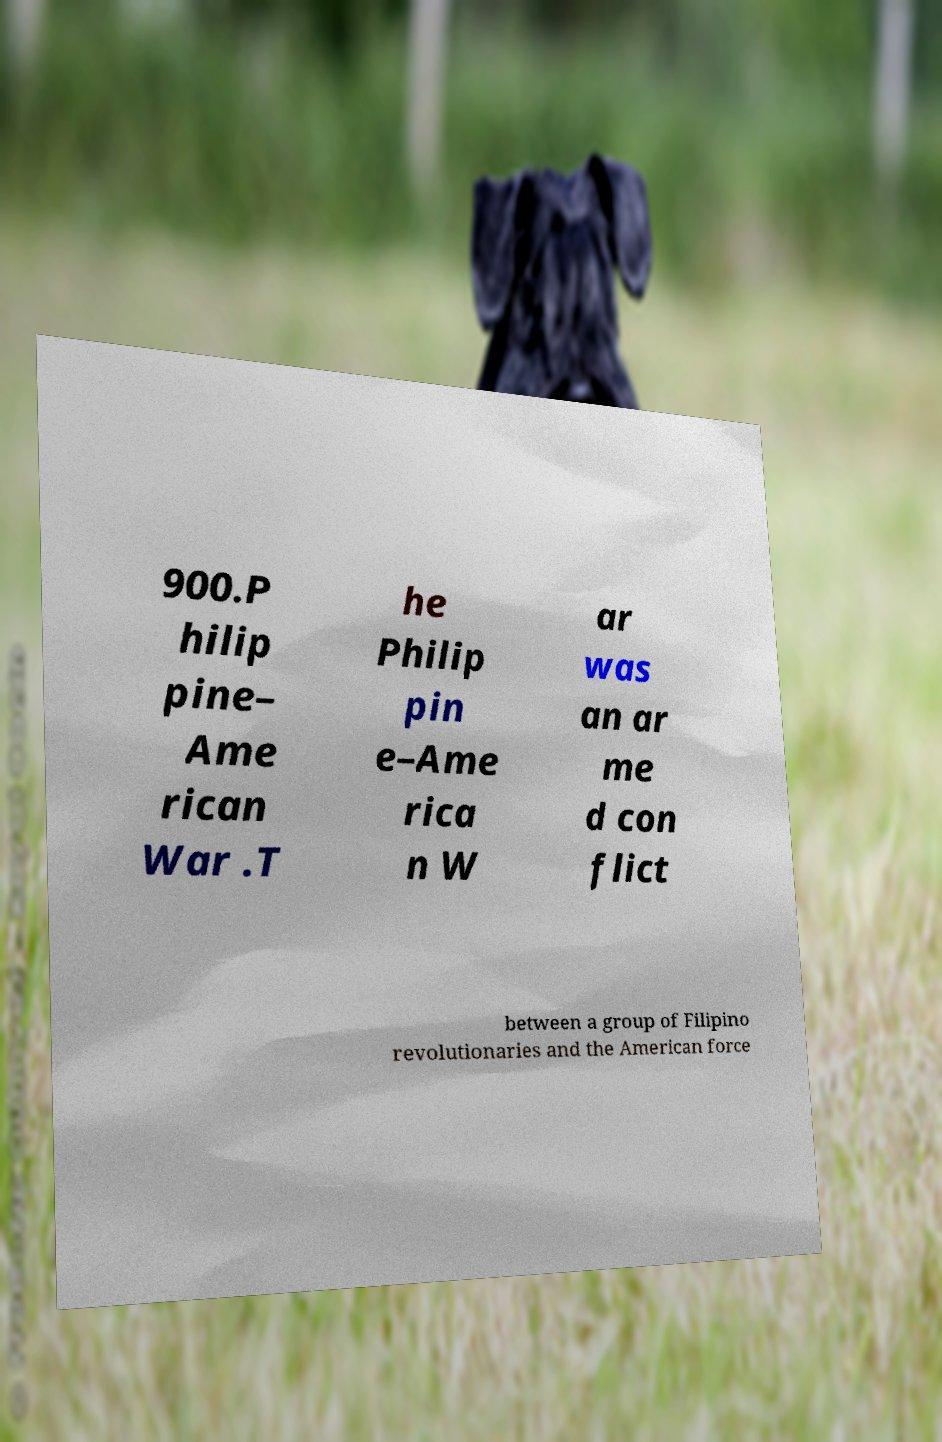Could you extract and type out the text from this image? 900.P hilip pine– Ame rican War .T he Philip pin e–Ame rica n W ar was an ar me d con flict between a group of Filipino revolutionaries and the American force 